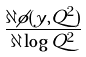Convert formula to latex. <formula><loc_0><loc_0><loc_500><loc_500>\frac { \partial \phi ( y , Q ^ { 2 } ) } { \partial \log Q ^ { 2 } }</formula> 